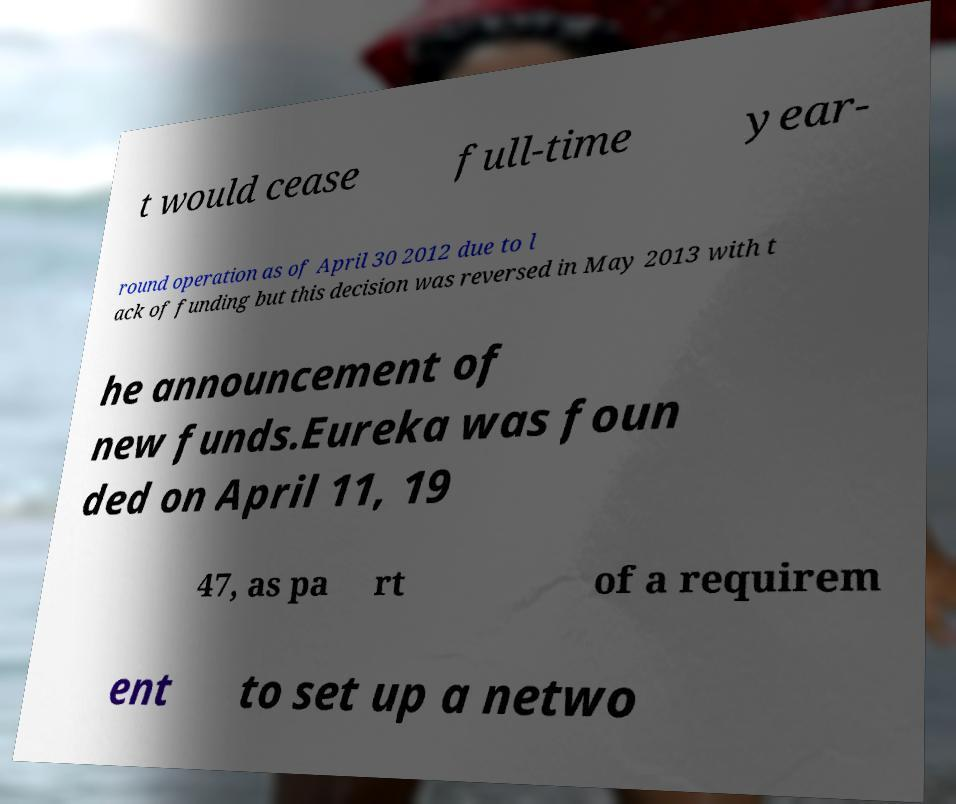Can you accurately transcribe the text from the provided image for me? t would cease full-time year- round operation as of April 30 2012 due to l ack of funding but this decision was reversed in May 2013 with t he announcement of new funds.Eureka was foun ded on April 11, 19 47, as pa rt of a requirem ent to set up a netwo 